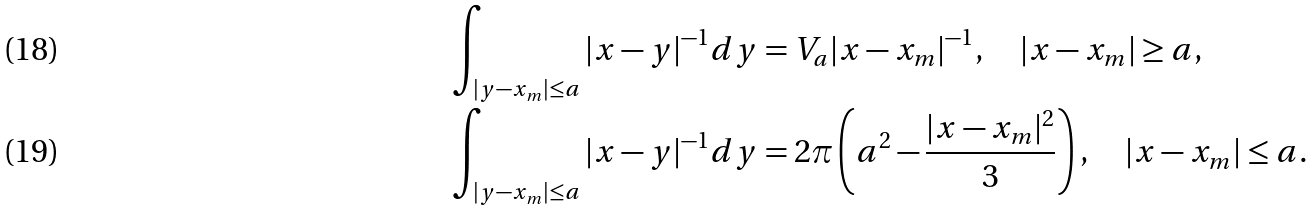<formula> <loc_0><loc_0><loc_500><loc_500>\int _ { | y - x _ { m } | \leq a } | x - y | ^ { - 1 } d y & = V _ { a } | x - x _ { m } | ^ { - 1 } , \quad | x - x _ { m } | \geq a , \\ \int _ { | y - x _ { m } | \leq a } | x - y | ^ { - 1 } d y & = 2 \pi \left ( a ^ { 2 } - \frac { | x - x _ { m } | ^ { 2 } } { 3 } \right ) , \quad | x - x _ { m } | \leq a .</formula> 